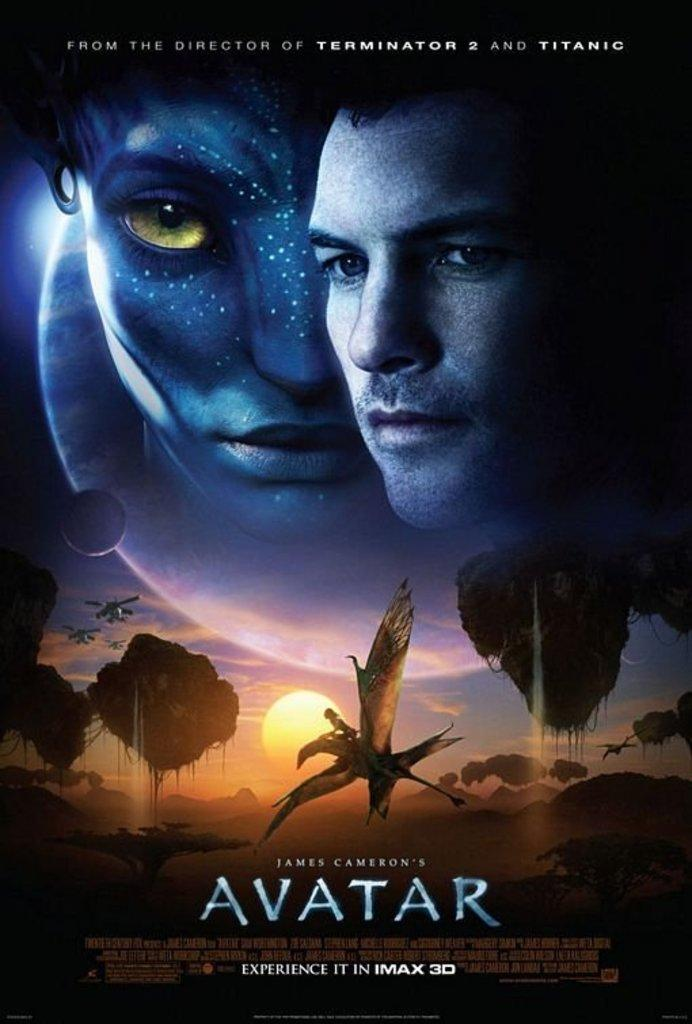<image>
Describe the image concisely. A poster for Avatar says that it will be in IMAX 3D. 